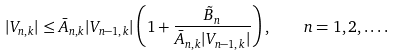<formula> <loc_0><loc_0><loc_500><loc_500>| V _ { n , k } | \leq \bar { A } _ { n , k } | V _ { n - 1 , k } | \left ( 1 + \frac { \tilde { B } _ { n } } { \bar { A } _ { n , k } | V _ { n - 1 , k } | } \right ) , \quad n = 1 , 2 , \dots .</formula> 